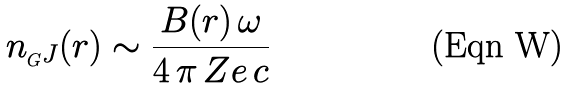Convert formula to latex. <formula><loc_0><loc_0><loc_500><loc_500>n _ { _ { G } J } ( r ) \sim \frac { B ( r ) \, \omega } { 4 \, \pi \, Z e \, c }</formula> 